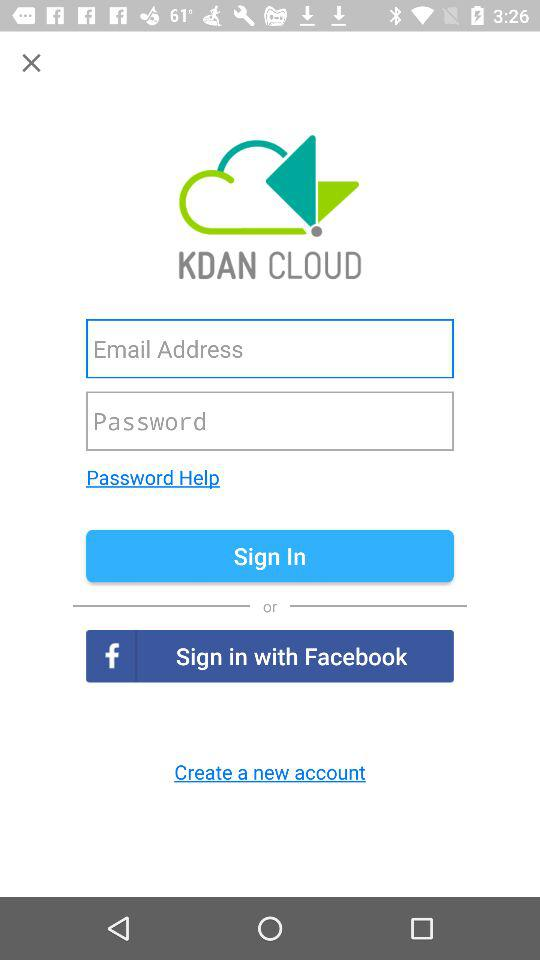What is the option available for logging in? The available options for logging in are "Email Address", "Password" and "Facebook". 